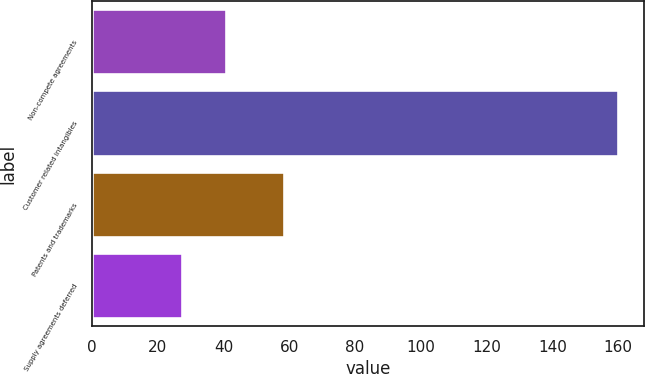<chart> <loc_0><loc_0><loc_500><loc_500><bar_chart><fcel>Non-compete agreements<fcel>Customer related intangibles<fcel>Patents and trademarks<fcel>Supply agreements deferred<nl><fcel>40.65<fcel>159.9<fcel>58.5<fcel>27.4<nl></chart> 